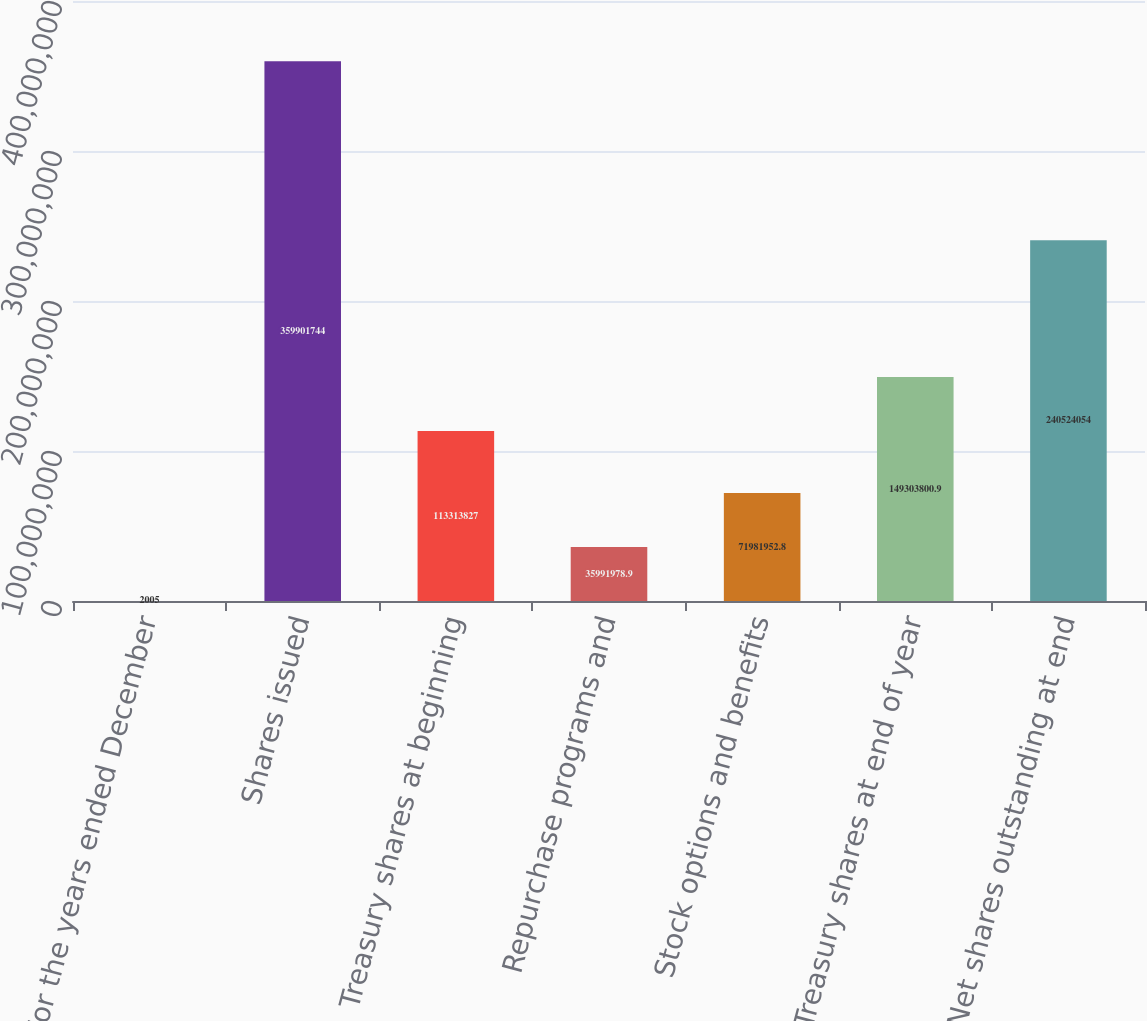Convert chart. <chart><loc_0><loc_0><loc_500><loc_500><bar_chart><fcel>For the years ended December<fcel>Shares issued<fcel>Treasury shares at beginning<fcel>Repurchase programs and<fcel>Stock options and benefits<fcel>Treasury shares at end of year<fcel>Net shares outstanding at end<nl><fcel>2005<fcel>3.59902e+08<fcel>1.13314e+08<fcel>3.5992e+07<fcel>7.1982e+07<fcel>1.49304e+08<fcel>2.40524e+08<nl></chart> 